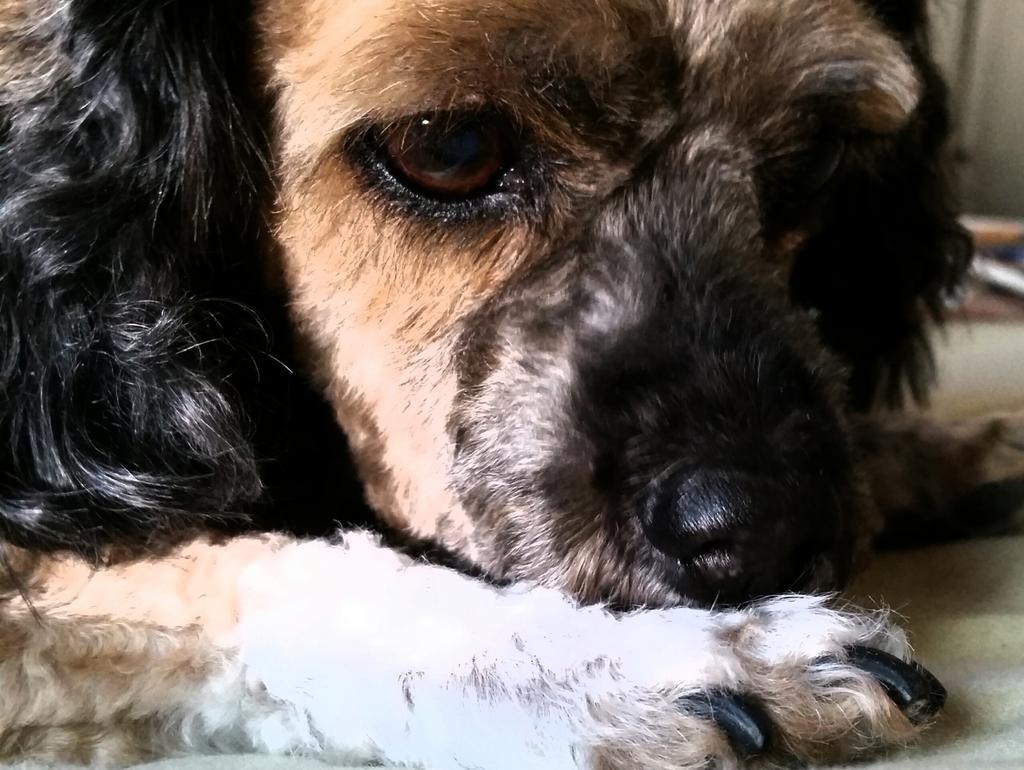Describe this image in one or two sentences. In this image, we can see a dog and the ground. 